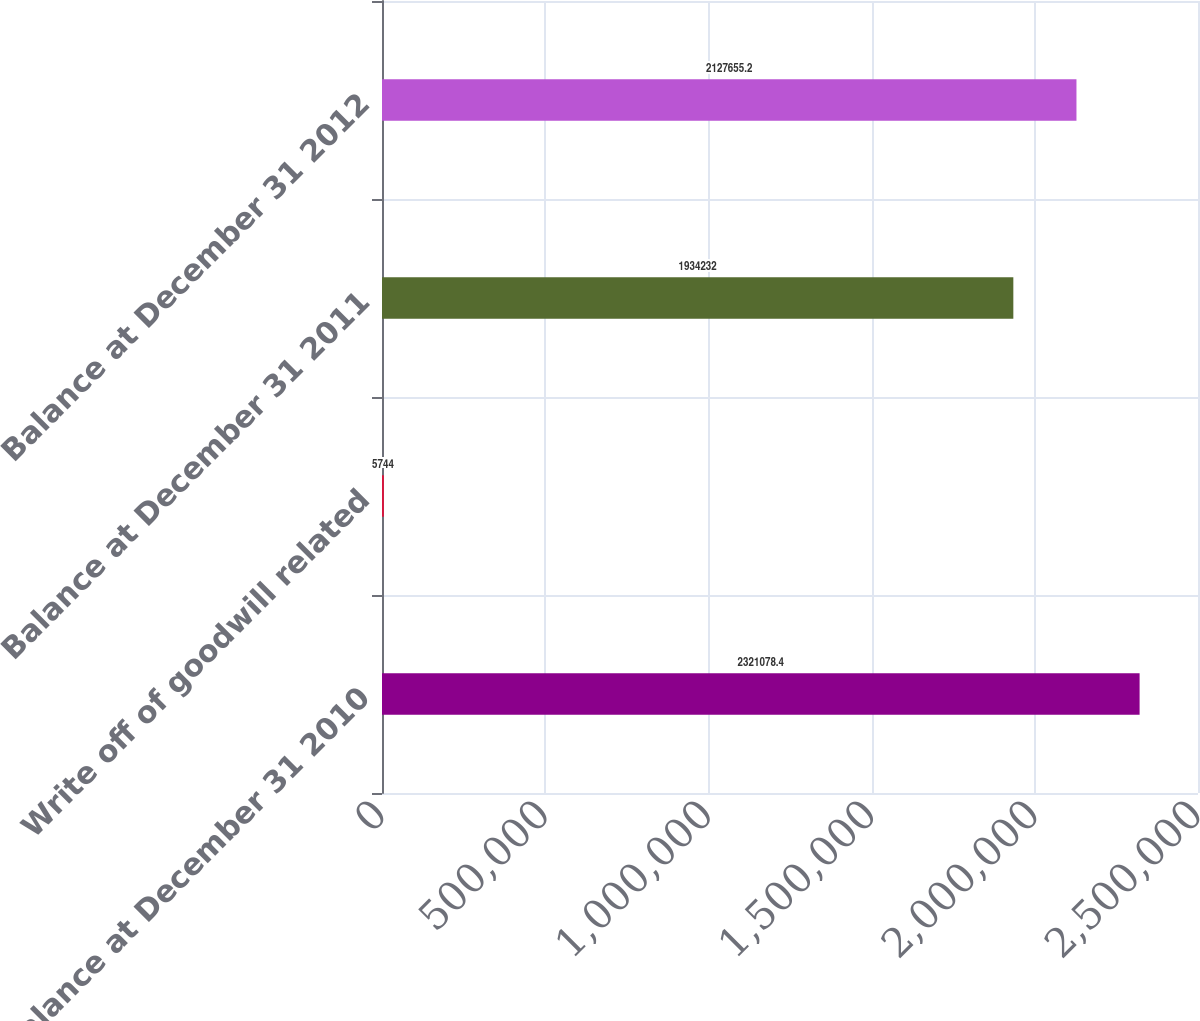<chart> <loc_0><loc_0><loc_500><loc_500><bar_chart><fcel>Balance at December 31 2010<fcel>Write off of goodwill related<fcel>Balance at December 31 2011<fcel>Balance at December 31 2012<nl><fcel>2.32108e+06<fcel>5744<fcel>1.93423e+06<fcel>2.12766e+06<nl></chart> 